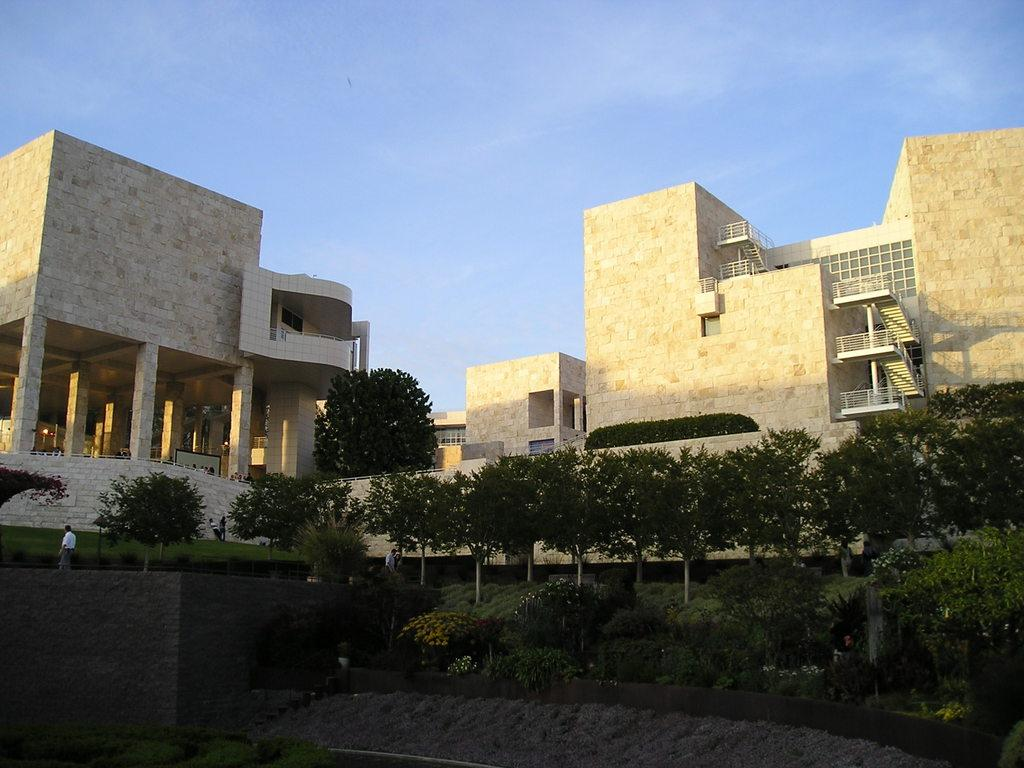What is located in the foreground of the image? There are plants and a person in the foreground of the image. What type of terrain is visible in the foreground of the image? There is grassland in the foreground of the image. What can be seen in the background of the image? There are buildings and the sky visible in the background of the image. How many dogs are wearing dresses in the image? There are no dogs or dresses present in the image. Can you describe the frogs sitting on the buildings in the background? There are no frogs present in the image; only buildings and the sky are visible in the background. 